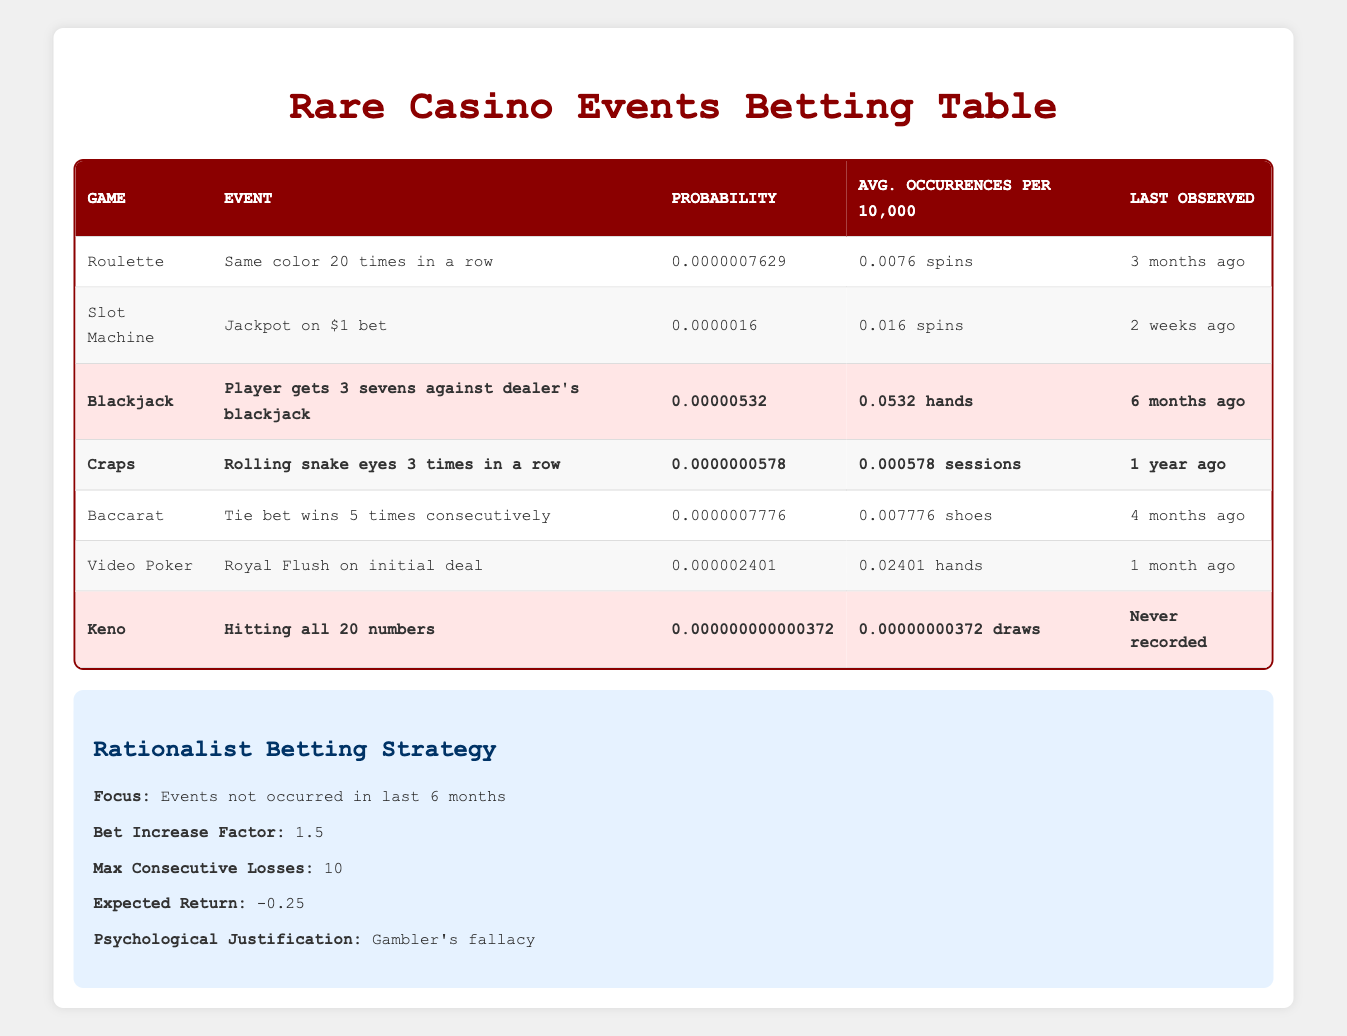What game has the lowest probability event? Looking at the table, the probability for each event is listed. The event for Keno, "Hitting all 20 numbers," has the lowest probability at 0.000000000000372.
Answer: Keno How many times has Blackjack's notable event occurred in the last 6 months? The table indicates that the last observed event for Blackjack, "Player gets 3 sevens against dealer's blackjack," was 6 months ago, meaning it has not occurred in that timeframe.
Answer: 0 times Which event observed most recently has the highest average occurrences per 10,000? The event "Jackpot on $1 bet," from the Slot Machine game, last observed 2 weeks ago, has an average occurrence of 0.016, which is the highest among the most recent events.
Answer: Jackpot on $1 bet What is the combined average occurrence rate for Blackjack and Craps? The average occurrences for Blackjack is 0.0532 and for Craps is 0.000578. Adding these, we get 0.0532 + 0.000578 = 0.053778 per 10,000 hands or sessions.
Answer: 0.053778 Is there any event that has never been recorded and what is it? The table lists "Hitting all 20 numbers" in Keno as an event that has never been recorded. Thus, the answer is yes, and the event is "Hitting all 20 numbers."
Answer: Yes, Hitting all 20 numbers What is the largest bet increase factor according to the strategy? The strategy states that the bet increase factor is 1.5. This is a specific detail provided in the strategy section of the table.
Answer: 1.5 Which two events have occurred in the last 4 to 6 months and are notable? The events are "Player gets 3 sevens against dealer's blackjack" (6 months ago) and "Tie bet wins 5 times consecutively" (4 months ago). Thus, these two events meet the criteria.
Answer: Blackjack and Baccarat How does the probability of winning a Royal Flush on Video Poker compare to rolling snake eyes 3 times in Craps? The probability of a Royal Flush on Video Poker is 0.000002401, while for rolling snake eyes in Craps, it is 0.0000000578. Dividing the two gives us a ratio: 0.000002401 / 0.0000000578 ≈ 41.5, indicating a Royal Flush is significantly more probable.
Answer: More probable by about 41.5 times 